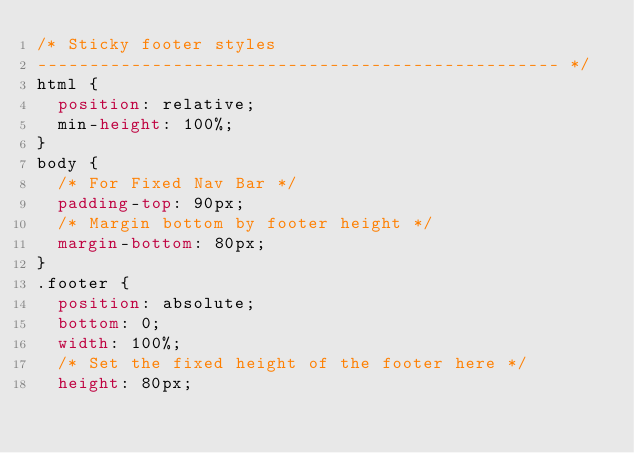Convert code to text. <code><loc_0><loc_0><loc_500><loc_500><_CSS_>/* Sticky footer styles
-------------------------------------------------- */
html {
  position: relative;
  min-height: 100%;
}
body {
  /* For Fixed Nav Bar */
  padding-top: 90px;
  /* Margin bottom by footer height */
  margin-bottom: 80px;
}
.footer {
  position: absolute;
  bottom: 0;
  width: 100%;
  /* Set the fixed height of the footer here */
  height: 80px;</code> 